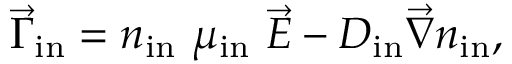<formula> <loc_0><loc_0><loc_500><loc_500>\vec { \Gamma } _ { i n } = n _ { i n } \, \mu _ { i n } \, \vec { E } - D _ { i n } \vec { \nabla } n _ { i n } ,</formula> 